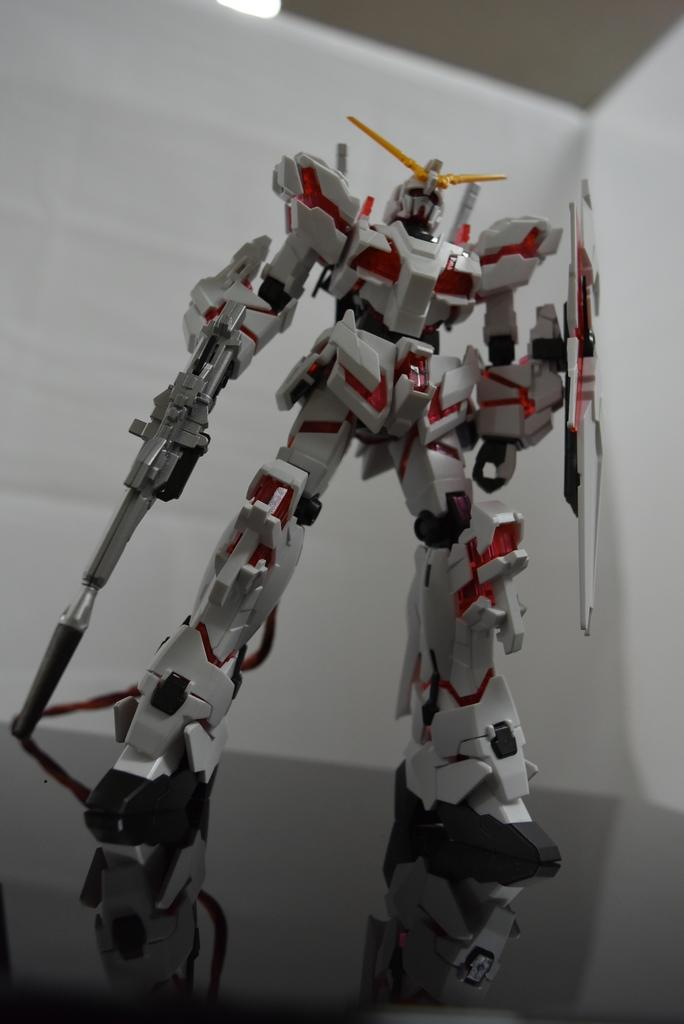What object is the main subject of the image? There is a toy robot in the image. Where is the toy robot located? The toy robot is on a surface. What can be seen in the background of the image? There is a white wall and light visible in the background of the image. How many dogs are present in the image, and what page are they on? There are no dogs present in the image, and the concept of a "page" is not applicable, as the image is not a book or document. 